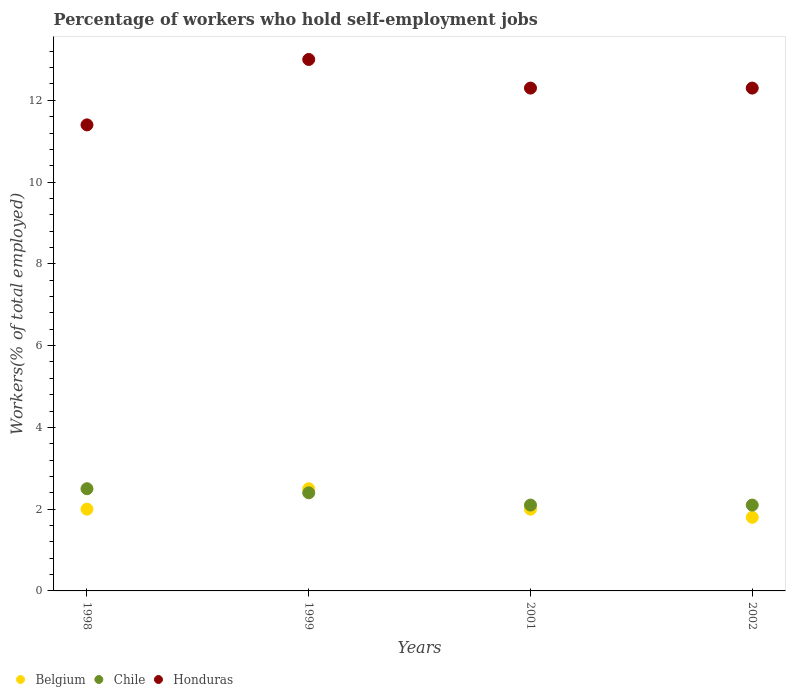Is the number of dotlines equal to the number of legend labels?
Keep it short and to the point. Yes. Across all years, what is the minimum percentage of self-employed workers in Honduras?
Your response must be concise. 11.4. What is the total percentage of self-employed workers in Chile in the graph?
Provide a succinct answer. 9.1. What is the difference between the percentage of self-employed workers in Belgium in 1998 and that in 1999?
Give a very brief answer. -0.5. What is the difference between the percentage of self-employed workers in Honduras in 1998 and the percentage of self-employed workers in Belgium in 1999?
Give a very brief answer. 8.9. What is the average percentage of self-employed workers in Chile per year?
Provide a succinct answer. 2.27. In the year 1999, what is the difference between the percentage of self-employed workers in Honduras and percentage of self-employed workers in Belgium?
Provide a succinct answer. 10.5. In how many years, is the percentage of self-employed workers in Chile greater than 11.6 %?
Offer a terse response. 0. What is the ratio of the percentage of self-employed workers in Honduras in 1998 to that in 2002?
Your response must be concise. 0.93. Is the difference between the percentage of self-employed workers in Honduras in 1998 and 2001 greater than the difference between the percentage of self-employed workers in Belgium in 1998 and 2001?
Ensure brevity in your answer.  No. What is the difference between the highest and the second highest percentage of self-employed workers in Honduras?
Your answer should be very brief. 0.7. What is the difference between the highest and the lowest percentage of self-employed workers in Chile?
Your answer should be very brief. 0.4. In how many years, is the percentage of self-employed workers in Belgium greater than the average percentage of self-employed workers in Belgium taken over all years?
Ensure brevity in your answer.  1. Is the sum of the percentage of self-employed workers in Honduras in 1998 and 2001 greater than the maximum percentage of self-employed workers in Belgium across all years?
Your answer should be compact. Yes. Does the percentage of self-employed workers in Chile monotonically increase over the years?
Your response must be concise. No. Is the percentage of self-employed workers in Belgium strictly less than the percentage of self-employed workers in Honduras over the years?
Provide a succinct answer. Yes. Are the values on the major ticks of Y-axis written in scientific E-notation?
Your answer should be compact. No. Does the graph contain grids?
Give a very brief answer. No. How are the legend labels stacked?
Keep it short and to the point. Horizontal. What is the title of the graph?
Offer a terse response. Percentage of workers who hold self-employment jobs. Does "Tajikistan" appear as one of the legend labels in the graph?
Your answer should be compact. No. What is the label or title of the X-axis?
Provide a short and direct response. Years. What is the label or title of the Y-axis?
Your answer should be very brief. Workers(% of total employed). What is the Workers(% of total employed) in Honduras in 1998?
Your answer should be compact. 11.4. What is the Workers(% of total employed) of Chile in 1999?
Give a very brief answer. 2.4. What is the Workers(% of total employed) of Honduras in 1999?
Give a very brief answer. 13. What is the Workers(% of total employed) of Belgium in 2001?
Provide a short and direct response. 2. What is the Workers(% of total employed) of Chile in 2001?
Your answer should be very brief. 2.1. What is the Workers(% of total employed) of Honduras in 2001?
Offer a terse response. 12.3. What is the Workers(% of total employed) in Belgium in 2002?
Give a very brief answer. 1.8. What is the Workers(% of total employed) of Chile in 2002?
Offer a very short reply. 2.1. What is the Workers(% of total employed) of Honduras in 2002?
Ensure brevity in your answer.  12.3. Across all years, what is the maximum Workers(% of total employed) in Honduras?
Provide a short and direct response. 13. Across all years, what is the minimum Workers(% of total employed) in Belgium?
Offer a very short reply. 1.8. Across all years, what is the minimum Workers(% of total employed) of Chile?
Your answer should be compact. 2.1. Across all years, what is the minimum Workers(% of total employed) of Honduras?
Give a very brief answer. 11.4. What is the total Workers(% of total employed) in Belgium in the graph?
Make the answer very short. 8.3. What is the total Workers(% of total employed) of Chile in the graph?
Make the answer very short. 9.1. What is the difference between the Workers(% of total employed) in Chile in 1998 and that in 1999?
Provide a succinct answer. 0.1. What is the difference between the Workers(% of total employed) of Honduras in 1998 and that in 1999?
Provide a short and direct response. -1.6. What is the difference between the Workers(% of total employed) of Belgium in 1998 and that in 2002?
Keep it short and to the point. 0.2. What is the difference between the Workers(% of total employed) in Belgium in 1999 and that in 2001?
Provide a succinct answer. 0.5. What is the difference between the Workers(% of total employed) in Honduras in 1999 and that in 2001?
Your response must be concise. 0.7. What is the difference between the Workers(% of total employed) of Belgium in 1999 and that in 2002?
Your answer should be very brief. 0.7. What is the difference between the Workers(% of total employed) of Chile in 1999 and that in 2002?
Keep it short and to the point. 0.3. What is the difference between the Workers(% of total employed) in Belgium in 2001 and that in 2002?
Give a very brief answer. 0.2. What is the difference between the Workers(% of total employed) of Honduras in 2001 and that in 2002?
Ensure brevity in your answer.  0. What is the difference between the Workers(% of total employed) of Belgium in 1998 and the Workers(% of total employed) of Chile in 1999?
Give a very brief answer. -0.4. What is the difference between the Workers(% of total employed) of Chile in 1998 and the Workers(% of total employed) of Honduras in 2001?
Offer a terse response. -9.8. What is the difference between the Workers(% of total employed) of Belgium in 1998 and the Workers(% of total employed) of Chile in 2002?
Your response must be concise. -0.1. What is the difference between the Workers(% of total employed) in Belgium in 1998 and the Workers(% of total employed) in Honduras in 2002?
Keep it short and to the point. -10.3. What is the difference between the Workers(% of total employed) of Chile in 1998 and the Workers(% of total employed) of Honduras in 2002?
Your response must be concise. -9.8. What is the difference between the Workers(% of total employed) of Belgium in 1999 and the Workers(% of total employed) of Chile in 2001?
Provide a short and direct response. 0.4. What is the difference between the Workers(% of total employed) in Belgium in 1999 and the Workers(% of total employed) in Honduras in 2001?
Give a very brief answer. -9.8. What is the difference between the Workers(% of total employed) in Chile in 1999 and the Workers(% of total employed) in Honduras in 2001?
Your response must be concise. -9.9. What is the difference between the Workers(% of total employed) in Belgium in 1999 and the Workers(% of total employed) in Chile in 2002?
Provide a short and direct response. 0.4. What is the difference between the Workers(% of total employed) of Belgium in 1999 and the Workers(% of total employed) of Honduras in 2002?
Ensure brevity in your answer.  -9.8. What is the difference between the Workers(% of total employed) in Belgium in 2001 and the Workers(% of total employed) in Honduras in 2002?
Keep it short and to the point. -10.3. What is the average Workers(% of total employed) of Belgium per year?
Keep it short and to the point. 2.08. What is the average Workers(% of total employed) in Chile per year?
Ensure brevity in your answer.  2.27. What is the average Workers(% of total employed) of Honduras per year?
Your answer should be compact. 12.25. In the year 1998, what is the difference between the Workers(% of total employed) in Belgium and Workers(% of total employed) in Chile?
Offer a terse response. -0.5. In the year 1998, what is the difference between the Workers(% of total employed) of Chile and Workers(% of total employed) of Honduras?
Give a very brief answer. -8.9. In the year 1999, what is the difference between the Workers(% of total employed) of Belgium and Workers(% of total employed) of Chile?
Provide a succinct answer. 0.1. In the year 1999, what is the difference between the Workers(% of total employed) in Belgium and Workers(% of total employed) in Honduras?
Your answer should be very brief. -10.5. In the year 2002, what is the difference between the Workers(% of total employed) of Belgium and Workers(% of total employed) of Chile?
Offer a terse response. -0.3. In the year 2002, what is the difference between the Workers(% of total employed) in Belgium and Workers(% of total employed) in Honduras?
Give a very brief answer. -10.5. What is the ratio of the Workers(% of total employed) of Chile in 1998 to that in 1999?
Offer a very short reply. 1.04. What is the ratio of the Workers(% of total employed) in Honduras in 1998 to that in 1999?
Offer a very short reply. 0.88. What is the ratio of the Workers(% of total employed) in Belgium in 1998 to that in 2001?
Ensure brevity in your answer.  1. What is the ratio of the Workers(% of total employed) in Chile in 1998 to that in 2001?
Your response must be concise. 1.19. What is the ratio of the Workers(% of total employed) in Honduras in 1998 to that in 2001?
Provide a succinct answer. 0.93. What is the ratio of the Workers(% of total employed) of Chile in 1998 to that in 2002?
Make the answer very short. 1.19. What is the ratio of the Workers(% of total employed) of Honduras in 1998 to that in 2002?
Give a very brief answer. 0.93. What is the ratio of the Workers(% of total employed) of Honduras in 1999 to that in 2001?
Provide a succinct answer. 1.06. What is the ratio of the Workers(% of total employed) in Belgium in 1999 to that in 2002?
Your answer should be very brief. 1.39. What is the ratio of the Workers(% of total employed) of Chile in 1999 to that in 2002?
Offer a very short reply. 1.14. What is the ratio of the Workers(% of total employed) of Honduras in 1999 to that in 2002?
Give a very brief answer. 1.06. What is the difference between the highest and the second highest Workers(% of total employed) in Honduras?
Offer a very short reply. 0.7. What is the difference between the highest and the lowest Workers(% of total employed) in Chile?
Your answer should be compact. 0.4. What is the difference between the highest and the lowest Workers(% of total employed) of Honduras?
Offer a very short reply. 1.6. 